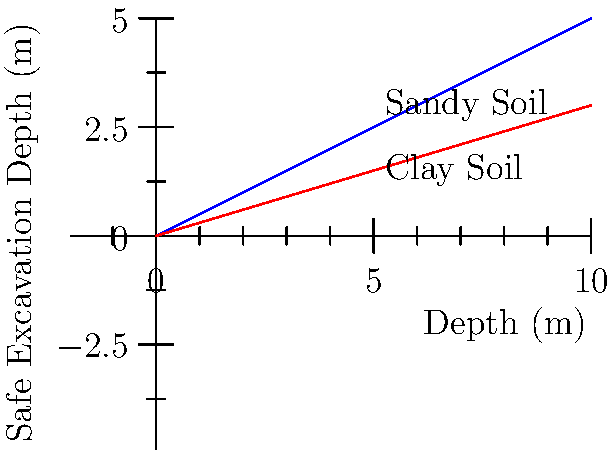As a store manager planning a renovation, you've been asked to understand the safe excavation depth for the project. The construction site has sandy soil, and there's a building 8 meters away from the excavation edge. Using the graph provided, which shows safe excavation depths for different soil types and distances from structures, what is the maximum safe excavation depth for this scenario? To determine the safe excavation depth, we'll follow these steps:

1. Identify the soil type: The question states we have sandy soil, so we'll use the blue line on the graph.

2. Locate the distance on the x-axis: The nearby building is 8 meters away, so we'll find 8 on the x-axis.

3. Find the corresponding y-value: From the 8-meter mark on the x-axis, we move up to the blue line (representing sandy soil).

4. Read the y-value: The y-value where the vertical line from 8 meters intersects the blue line gives us the safe excavation depth.

5. Interpret the result: The graph shows that for sandy soil at 8 meters distance, the safe excavation depth is approximately 4 meters.

This depth ensures the stability of both the excavation and the nearby structure, considering the soil type and distance.
Answer: 4 meters 